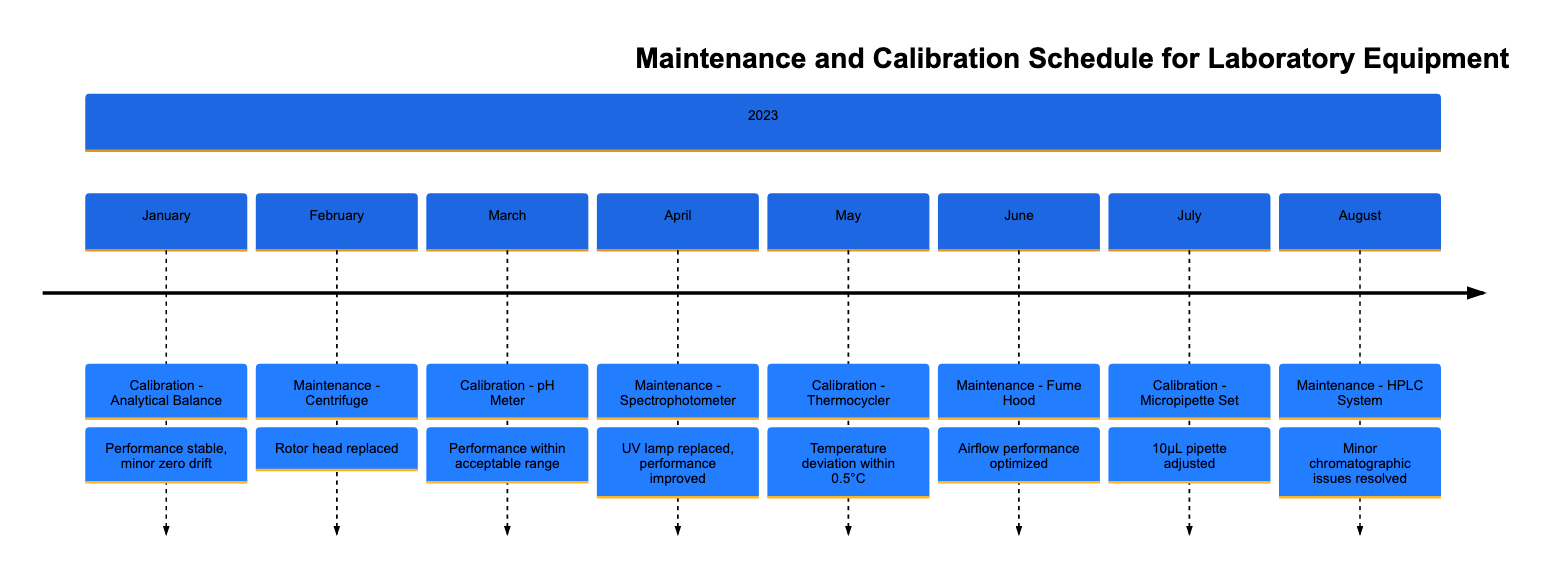What was the most recent calibration event? The most recent event in the timeline is the calibration of the HPLC System that occurred in August 2023. This can be identified by looking at the sequence of events listed in the timeline and finding the last occurrence of a calibration event.
Answer: HPLC System How many calibration events are listed in the timeline? To determine the number of calibration events, we can count the entries in the timeline where the event is labeled as "Calibration." There are four such events: Analytical Balance, pH Meter, Thermocycler, and Micropipette Set.
Answer: 4 What maintenance was performed on the Centrifuge? The details for the maintenance on the Centrifuge can be found under the month of February in the timeline, which states that the rotor head was replaced following an inspection.
Answer: Rotor head replaced Which equipment had a minor zero drift detected during calibration? The timeline indicates that the Analytical Balance needed calibration in January 2023, where it notes a minor zero drift issue. This was specifically mentioned in the notes section for that event.
Answer: Analytical Balance What were the performance issues noted for the Micropipette Set? In July 2023, the Micropipette Set underwent calibration, where it was noted that there was a deviation detected specifically in the 10µL pipette, requiring adjustment.
Answer: Deviation in the 10µL pipette Which equipment had its UV lamp replaced during maintenance? The timeline entry for April 2023 specifically states that during maintenance, the UV lamp of the Spectrophotometer was replaced, leading to improved performance. This can be easily extracted from the maintenance notes.
Answer: Spectrophotometer What equipment was serviced in June 2023? The entry for June 2023 in the timeline specifies that the Fume Hood was maintained, including inspections and cleaning operations relating to air filters and airflow adjustments.
Answer: Fume Hood Which month had the calibration of the Thermocycler? The timeline explicitly lists the calibration of the Thermocycler occurring in May 2023. This can be found by locating the entry corresponding to that month.
Answer: May 